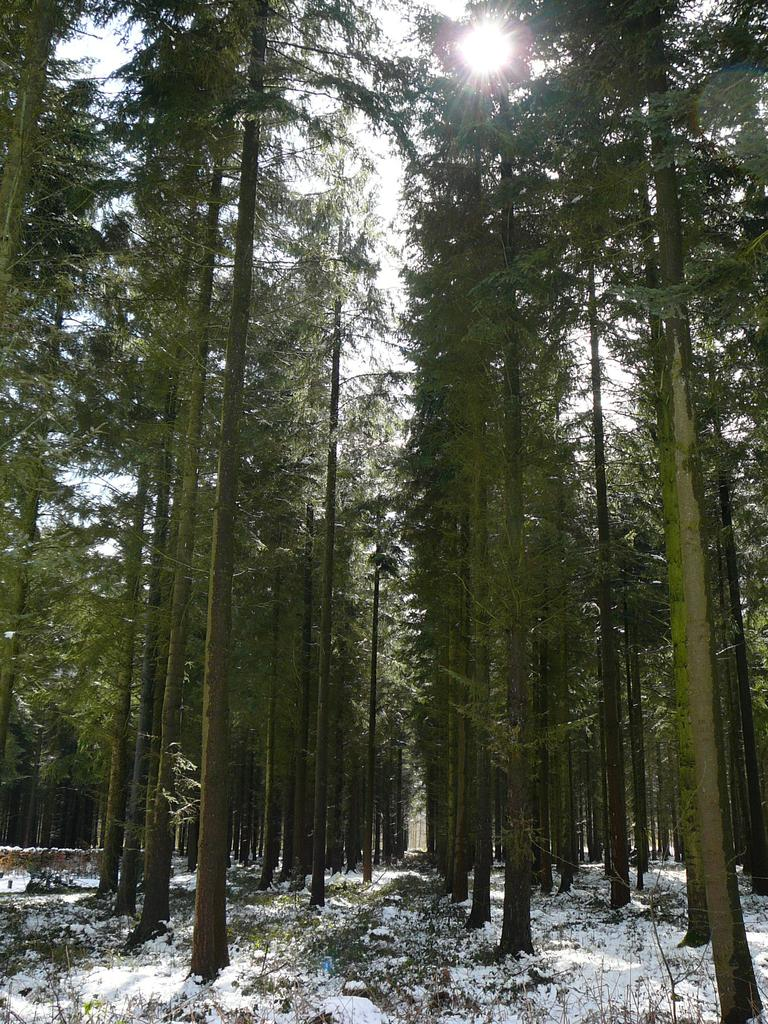What is the primary feature of the landscape in the image? There is snow in the image. What type of natural elements can be seen in the image? There are trees in the image. What can be seen in the distance in the image? The sky is visible in the background of the image. How many horses are visible on the island in the image? There is no island or horses present in the image; it features snow and trees. 